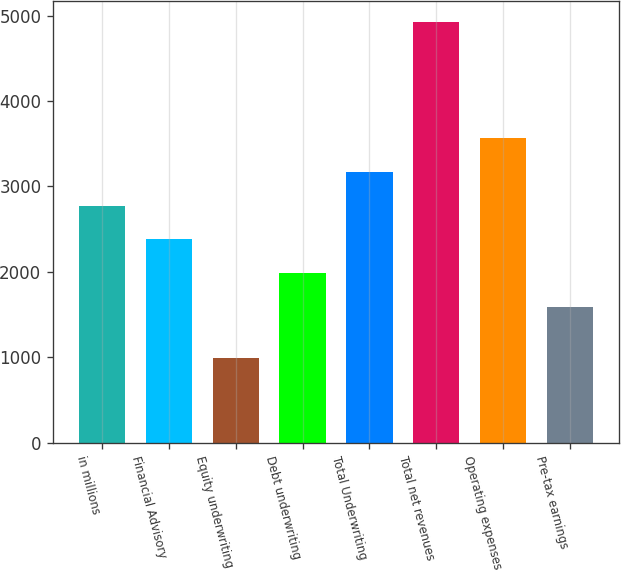Convert chart. <chart><loc_0><loc_0><loc_500><loc_500><bar_chart><fcel>in millions<fcel>Financial Advisory<fcel>Equity underwriting<fcel>Debt underwriting<fcel>Total Underwriting<fcel>Total net revenues<fcel>Operating expenses<fcel>Pre-tax earnings<nl><fcel>2774.7<fcel>2380.8<fcel>987<fcel>1986.9<fcel>3168.6<fcel>4926<fcel>3562.5<fcel>1593<nl></chart> 